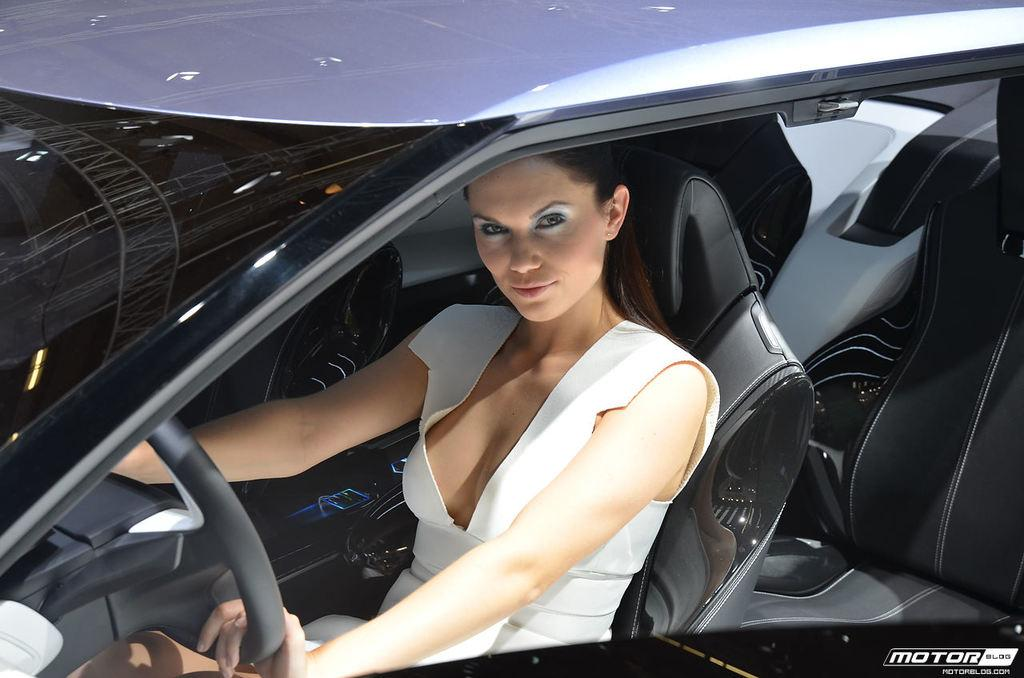What is the main subject of the image? The main subject of the image is a car. Who is inside the car? A woman is sitting in the car. What is the woman doing in the car? The woman is holding a steering wheel. How many boats can be seen in the image? There are no boats present in the image; it features a car with a woman holding a steering wheel. What type of battle is taking place in the image? There is no battle depicted in the image; it shows a car with a woman holding a steering wheel. 